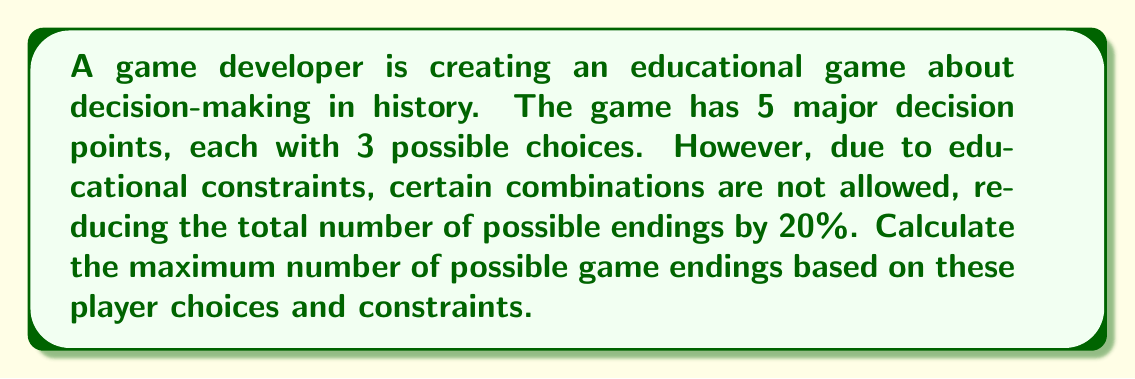What is the answer to this math problem? Let's approach this step-by-step:

1) First, we calculate the total number of possible endings without constraints:
   $$3^5 = 243$$
   This is because there are 3 choices for each of the 5 decision points.

2) Now, we need to reduce this by 20% due to the educational constraints:
   $$243 \times (1 - 0.20) = 243 \times 0.80 = 194.4$$

3) Since we can't have a fractional number of endings, we round down to the nearest whole number:
   $$\lfloor 194.4 \rfloor = 194$$

Therefore, the maximum number of possible game endings, considering the educational constraints, is 194.
Answer: 194 